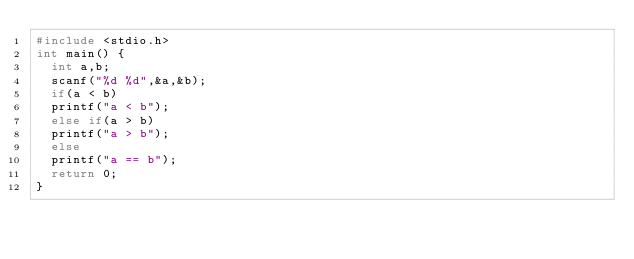<code> <loc_0><loc_0><loc_500><loc_500><_C_>#include <stdio.h>
int main() {
	int a,b;
	scanf("%d %d",&a,&b);
	if(a < b)
	printf("a < b");
	else if(a > b)
	printf("a > b");
	else
	printf("a == b");
	return 0;
}
</code> 